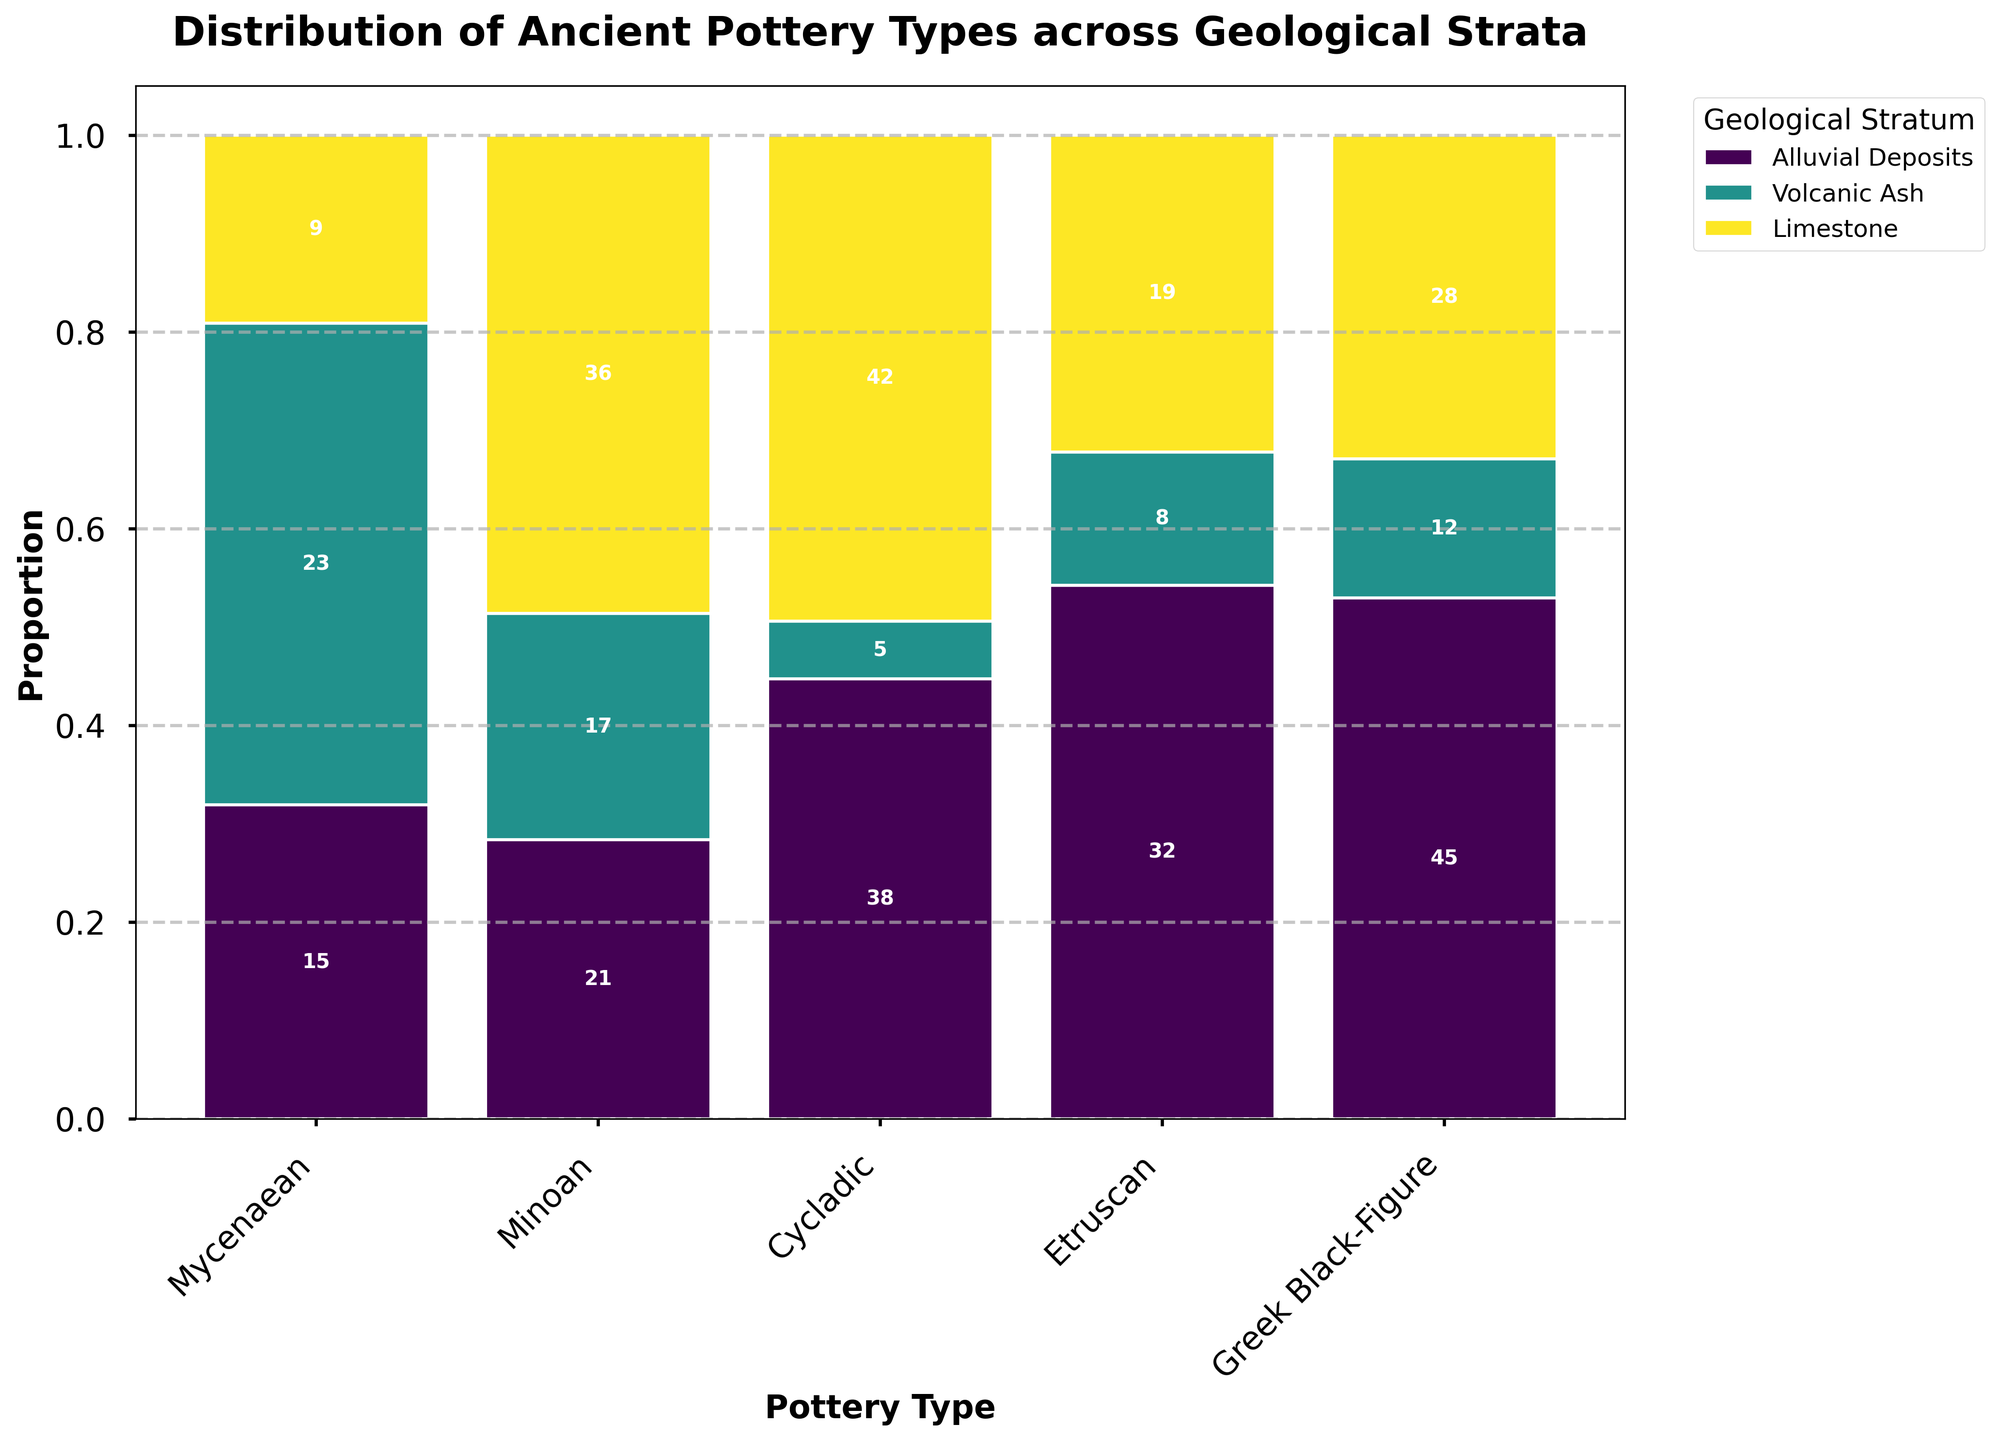What is the title of the plot? The title of the plot is displayed at the top and summarizes the main topic of the figure. By looking at the top of the plot, we can see the title "Distribution of Ancient Pottery Types across Geological Strata."
Answer: Distribution of Ancient Pottery Types across Geological Strata Which geological stratum contains the highest total count of Mycenaean pottery? To find this, we need to compare the height bars for Mycenaean pottery across all geological strata. The highest bar is the one for Alluvial Deposits with a count of 45, followed by Limestone with 28.
Answer: Alluvial Deposits What is the sum of Etruscan pottery found across all geological strata? We need to sum the counts of Etruscan pottery in the Alluvial Deposits, Volcanic Ash, and Limestone strata. The counts are 21, 17, and 36 respectively. So, 21 + 17 + 36 = 74.
Answer: 74 Among the geological strata, which one has the smallest proportion of Greek Black-Figure pottery? By inspecting the plot's proportions, Volcanic Ash has the smallest segment for Greek Black-Figure pottery, indicating the lowest proportion.
Answer: Volcanic Ash Which pottery type is most abundant in Limestone? We need to look at the highest count within the Limestone stratum. Greek Black-Figure pottery has the highest count of 42 in the Limestone stratum.
Answer: Greek Black-Figure What is the average number of Minoan pottery pieces found across the three geological strata? We need to sum the counts of Minoan pottery in Alluvial Deposits, Volcanic Ash, and Limestone, which are 32, 8, and 19 respectively. The total count is 32 + 8 + 19 = 59. The average is calculated as 59 / 3 ≈ 19.67.
Answer: 19.67 Are there more Cycladic pottery pieces in Volcanic Ash or Limestone? To compare, we look at the counts of Cycladic pottery; Volcanic Ash has 23 pieces while Limestone has 9 pieces. Clearly, Volcanic Ash has more.
Answer: Volcanic Ash Which geological stratum has the largest diversity in the types of pottery found (i.e., presence of different types)? To determine the diversity, observe which geological stratum has segments for all pottery types. Alluvial Deposits have segments for Mycenaean, Minoan, Cycladic, Etruscan, and Greek Black-Figure pottery, indicating the highest diversity.
Answer: Alluvial Deposits How does the proportion of Mycenaean pottery in Limestone compare to that in Volcanic Ash? We look at the heights of the respective segments and calculate proportions if necessary. The proportion for Mycenaean pottery in Limestone is higher than that in Volcanic Ash.
Answer: Higher in Limestone Which pottery type has the least overall counts across all geological strata? Summing up the counts for each pottery type across all strata and comparing them, Cycladic pottery has the lowest cumulative count (15 + 23 + 9 = 47).
Answer: Cycladic 